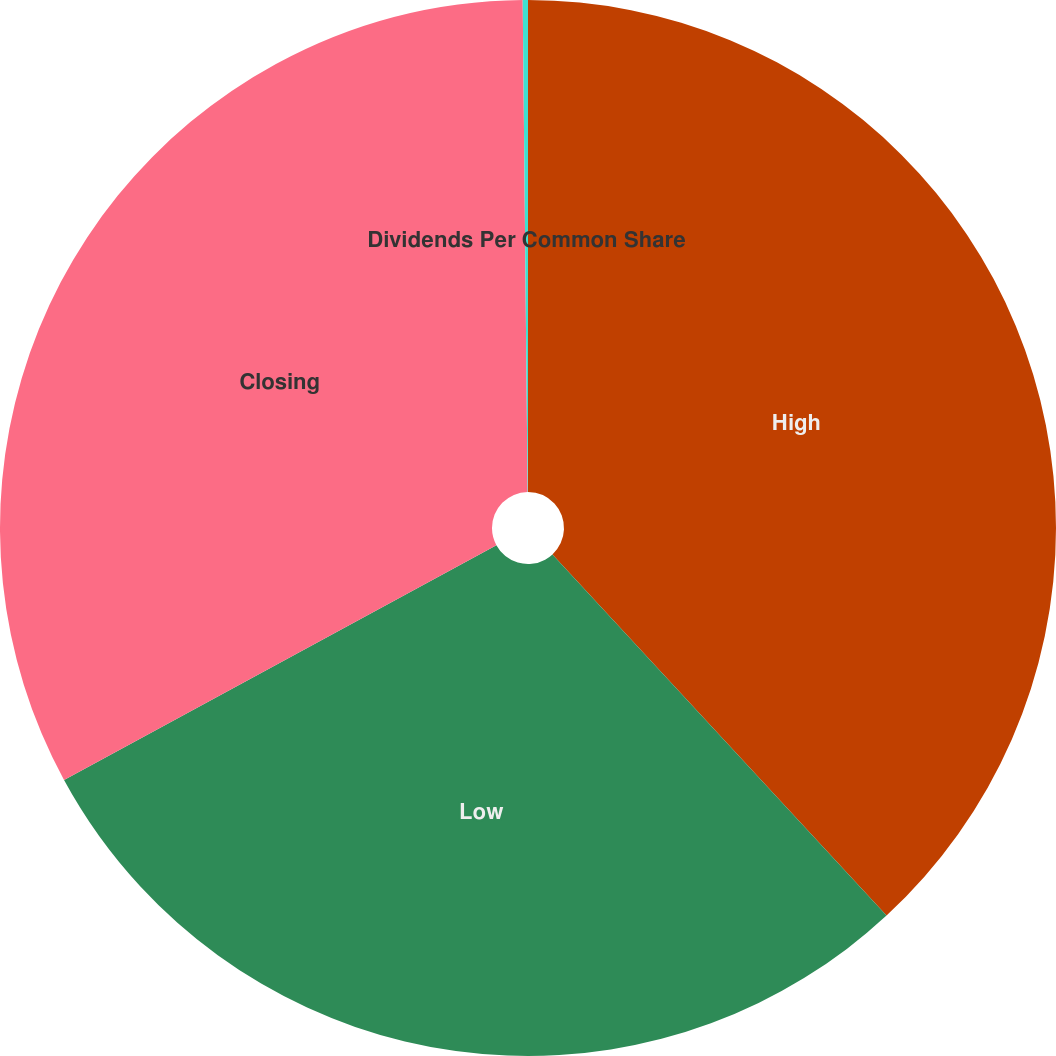Convert chart. <chart><loc_0><loc_0><loc_500><loc_500><pie_chart><fcel>High<fcel>Low<fcel>Closing<fcel>Dividends Per Common Share<nl><fcel>38.12%<fcel>28.96%<fcel>32.76%<fcel>0.16%<nl></chart> 